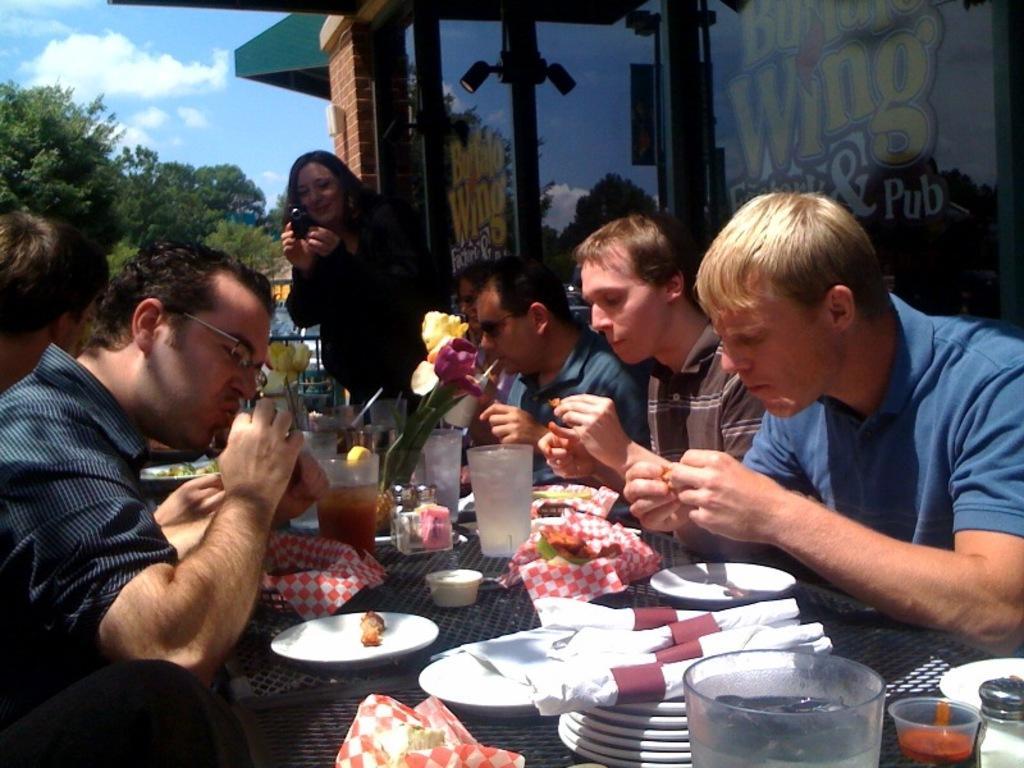Could you give a brief overview of what you see in this image? At the bottom of the image there is a table, on the table there are some plates and glasses and clothes and cups. Surrounding the table few people are sitting and holding some food. Behind them a woman is standing and holding a camera. In the top right corner of the image there is a house. In the top left corner of the image there are some trees. Behind the trees there are some clouds in the sky. 